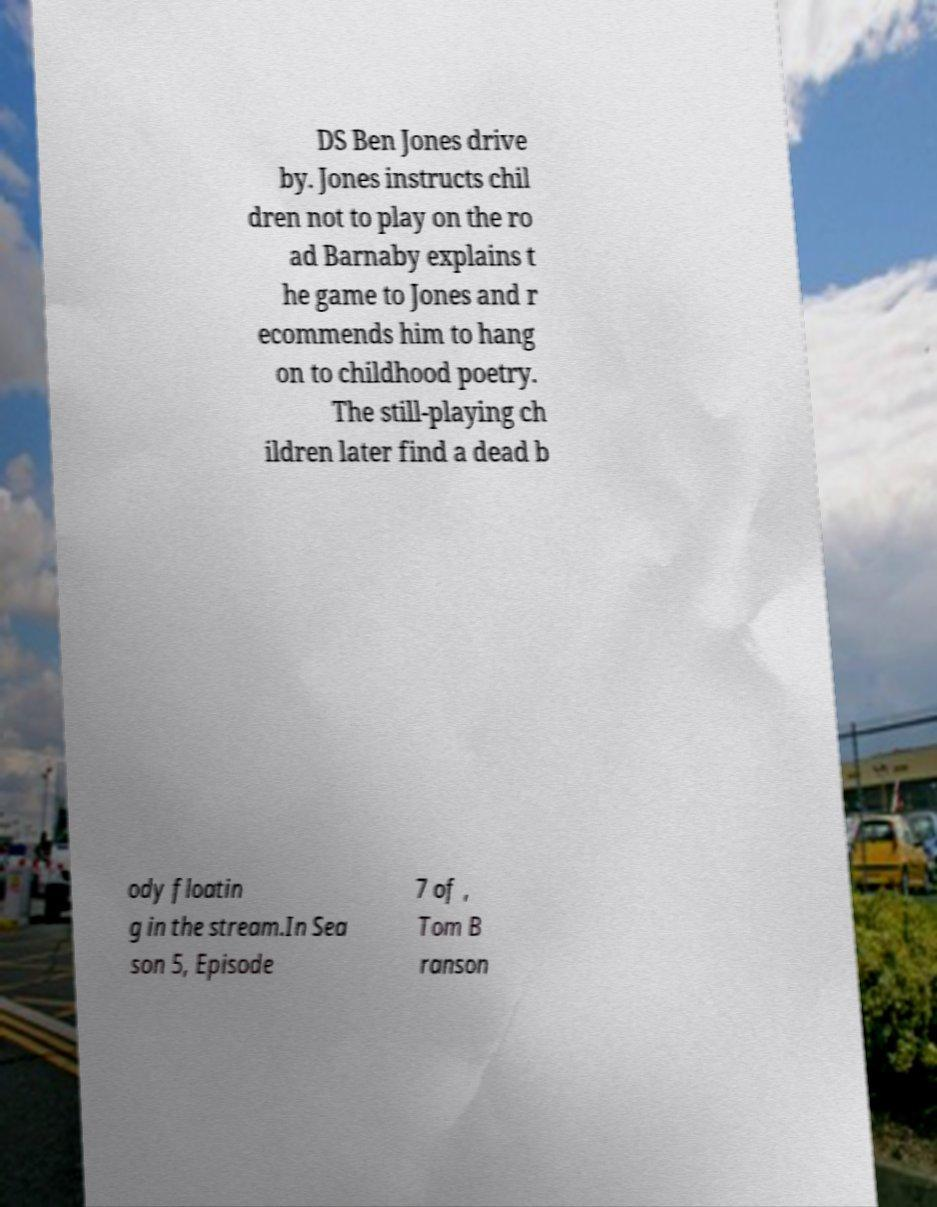What messages or text are displayed in this image? I need them in a readable, typed format. DS Ben Jones drive by. Jones instructs chil dren not to play on the ro ad Barnaby explains t he game to Jones and r ecommends him to hang on to childhood poetry. The still-playing ch ildren later find a dead b ody floatin g in the stream.In Sea son 5, Episode 7 of , Tom B ranson 